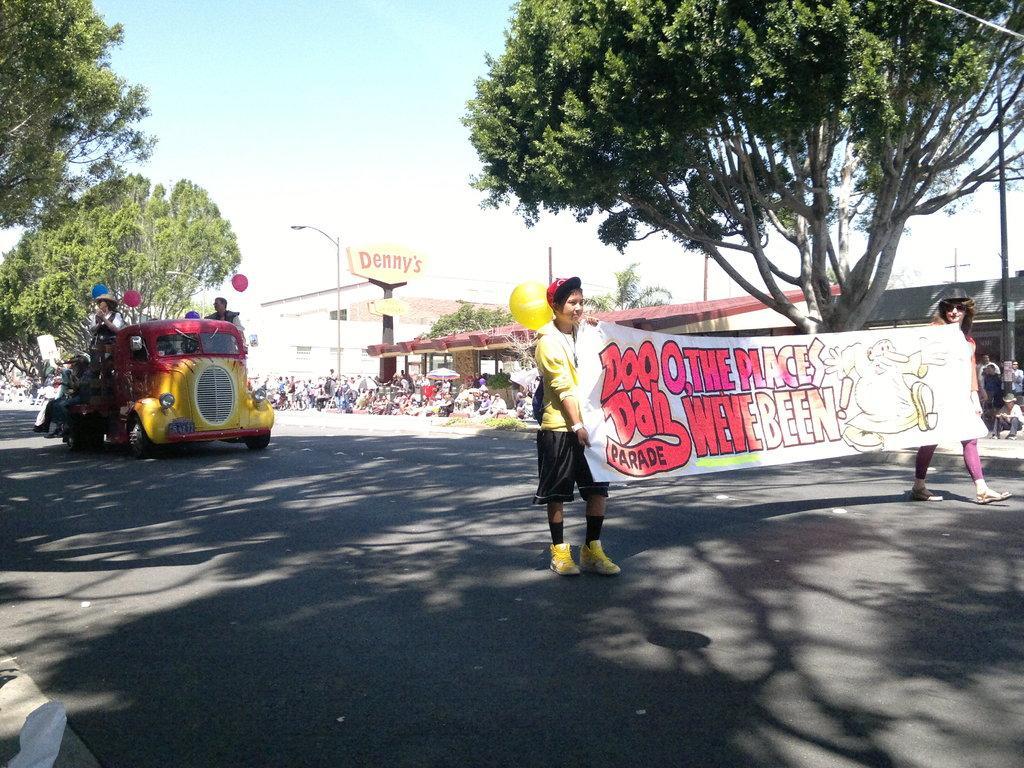Can you describe this image briefly? In the picture I can see people, vehicles and buildings. In front of the image I can see two people are holding banner. In the background I can see the sky, trees, street lights, poles and some other objects on the ground. 